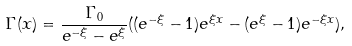Convert formula to latex. <formula><loc_0><loc_0><loc_500><loc_500>\Gamma ( x ) = \frac { \Gamma _ { 0 } } { e ^ { - \xi } - e ^ { \xi } } ( ( e ^ { - \xi } - 1 ) e ^ { \xi x } - ( e ^ { \xi } - 1 ) e ^ { - \xi x } ) ,</formula> 